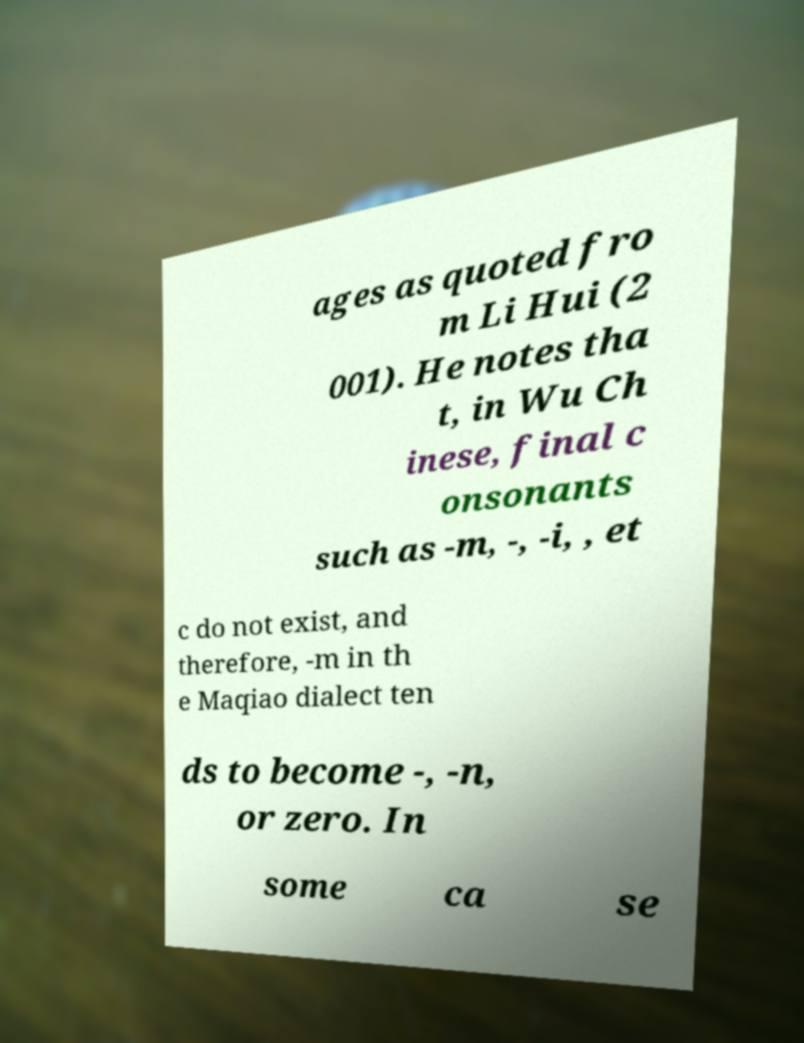Could you extract and type out the text from this image? ages as quoted fro m Li Hui (2 001). He notes tha t, in Wu Ch inese, final c onsonants such as -m, -, -i, , et c do not exist, and therefore, -m in th e Maqiao dialect ten ds to become -, -n, or zero. In some ca se 